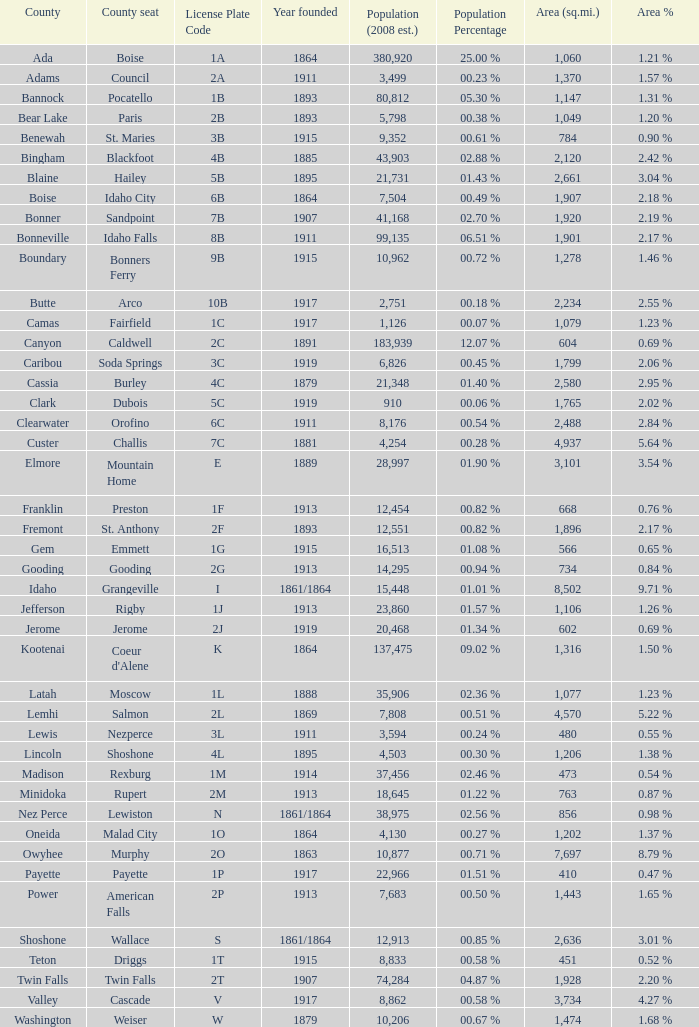In which country with a land area of 784 can you find the specific license plate code? 3B. 